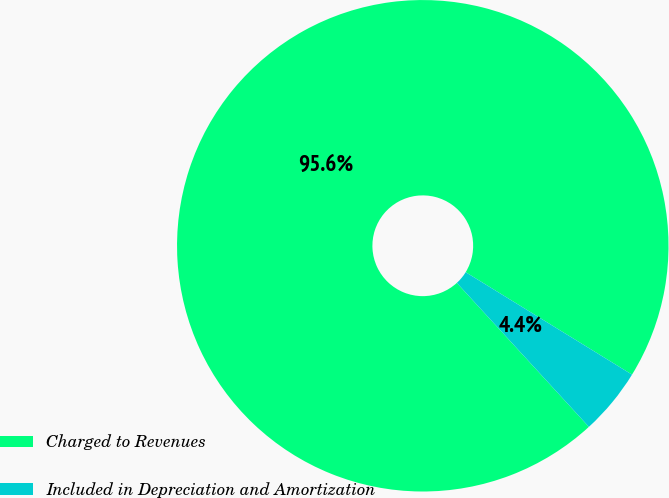Convert chart. <chart><loc_0><loc_0><loc_500><loc_500><pie_chart><fcel>Charged to Revenues<fcel>Included in Depreciation and Amortization<nl><fcel>95.6%<fcel>4.4%<nl></chart> 